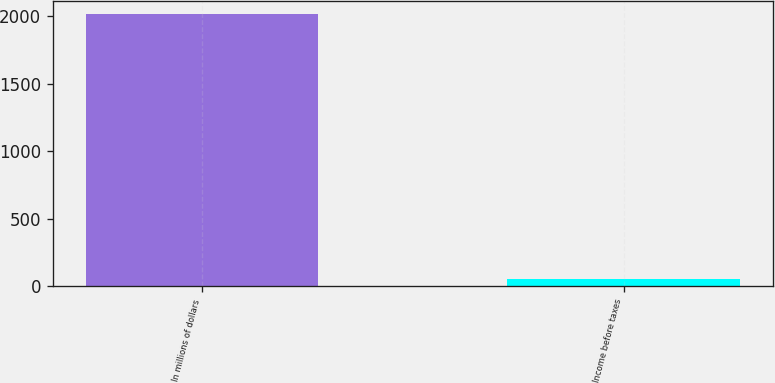Convert chart to OTSL. <chart><loc_0><loc_0><loc_500><loc_500><bar_chart><fcel>In millions of dollars<fcel>Income before taxes<nl><fcel>2015<fcel>54<nl></chart> 